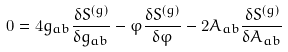<formula> <loc_0><loc_0><loc_500><loc_500>0 = 4 g _ { a b } \frac { \delta S ^ { ( g ) } } { \delta g _ { a b } } - \varphi \frac { \delta S ^ { ( g ) } } { \delta \varphi } - 2 A _ { a b } \frac { \delta S ^ { ( g ) } } { \delta A _ { a b } }</formula> 